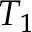<formula> <loc_0><loc_0><loc_500><loc_500>T _ { 1 }</formula> 